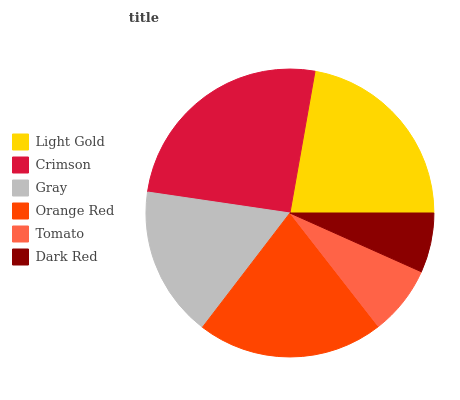Is Dark Red the minimum?
Answer yes or no. Yes. Is Crimson the maximum?
Answer yes or no. Yes. Is Gray the minimum?
Answer yes or no. No. Is Gray the maximum?
Answer yes or no. No. Is Crimson greater than Gray?
Answer yes or no. Yes. Is Gray less than Crimson?
Answer yes or no. Yes. Is Gray greater than Crimson?
Answer yes or no. No. Is Crimson less than Gray?
Answer yes or no. No. Is Orange Red the high median?
Answer yes or no. Yes. Is Gray the low median?
Answer yes or no. Yes. Is Crimson the high median?
Answer yes or no. No. Is Dark Red the low median?
Answer yes or no. No. 